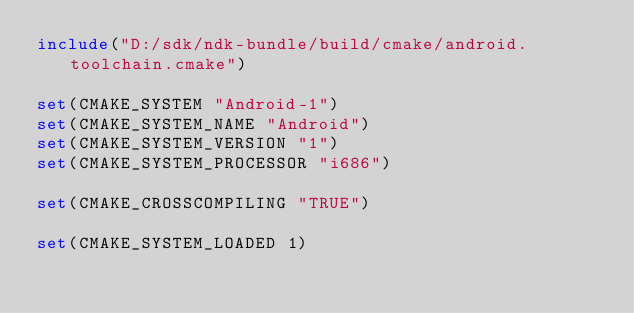<code> <loc_0><loc_0><loc_500><loc_500><_CMake_>include("D:/sdk/ndk-bundle/build/cmake/android.toolchain.cmake")

set(CMAKE_SYSTEM "Android-1")
set(CMAKE_SYSTEM_NAME "Android")
set(CMAKE_SYSTEM_VERSION "1")
set(CMAKE_SYSTEM_PROCESSOR "i686")

set(CMAKE_CROSSCOMPILING "TRUE")

set(CMAKE_SYSTEM_LOADED 1)
</code> 